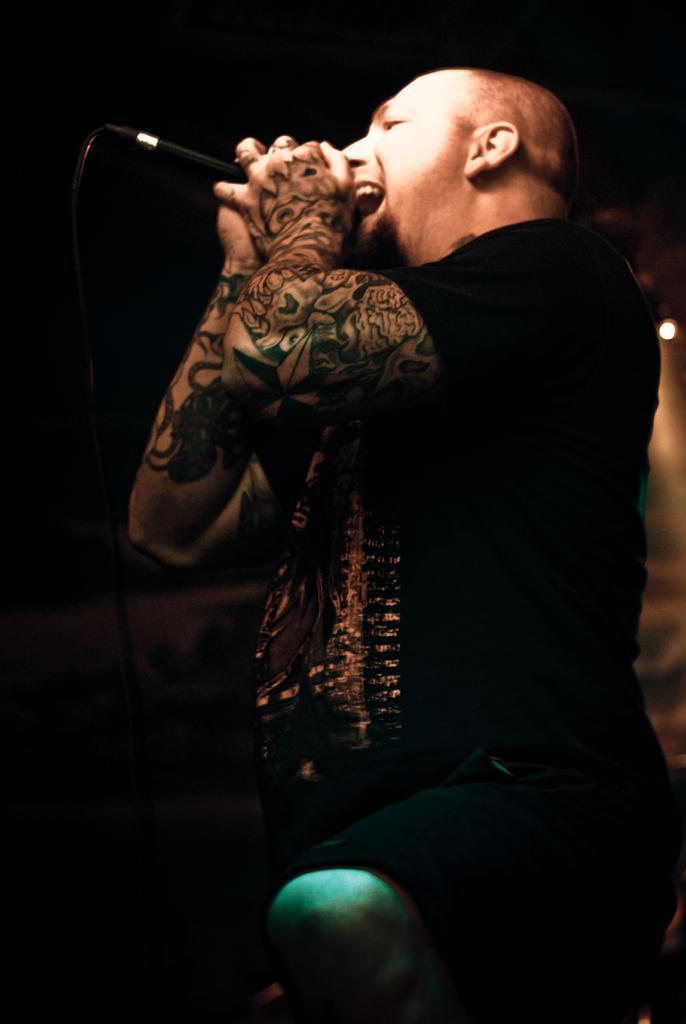Can you describe this image briefly? In this image it seems like a man is holding the mic and singing. 